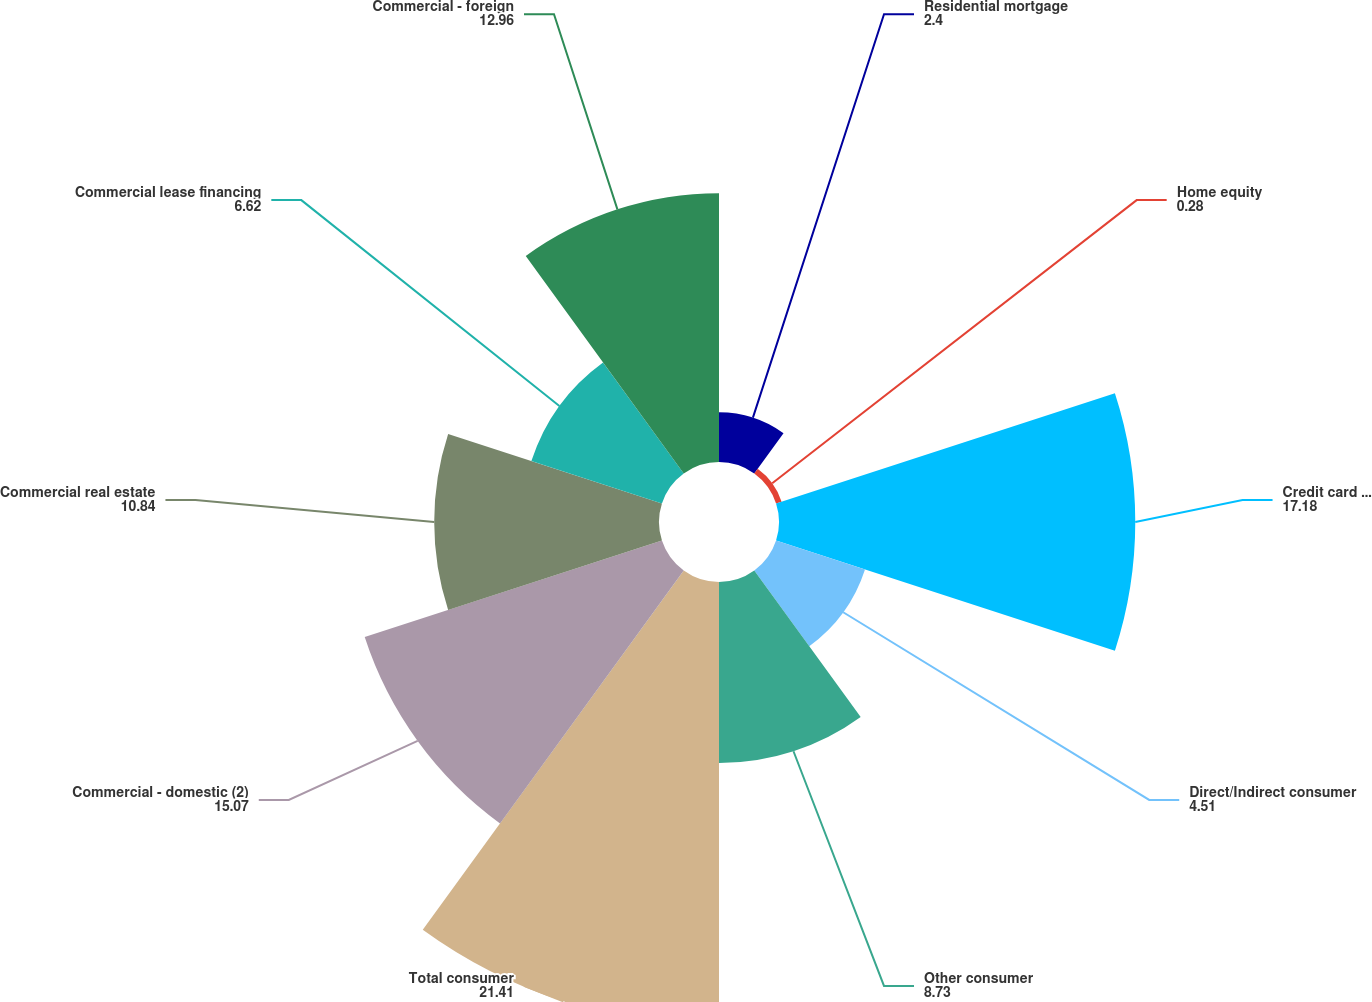<chart> <loc_0><loc_0><loc_500><loc_500><pie_chart><fcel>Residential mortgage<fcel>Home equity<fcel>Credit card - domestic<fcel>Direct/Indirect consumer<fcel>Other consumer<fcel>Total consumer<fcel>Commercial - domestic (2)<fcel>Commercial real estate<fcel>Commercial lease financing<fcel>Commercial - foreign<nl><fcel>2.4%<fcel>0.28%<fcel>17.18%<fcel>4.51%<fcel>8.73%<fcel>21.41%<fcel>15.07%<fcel>10.84%<fcel>6.62%<fcel>12.96%<nl></chart> 